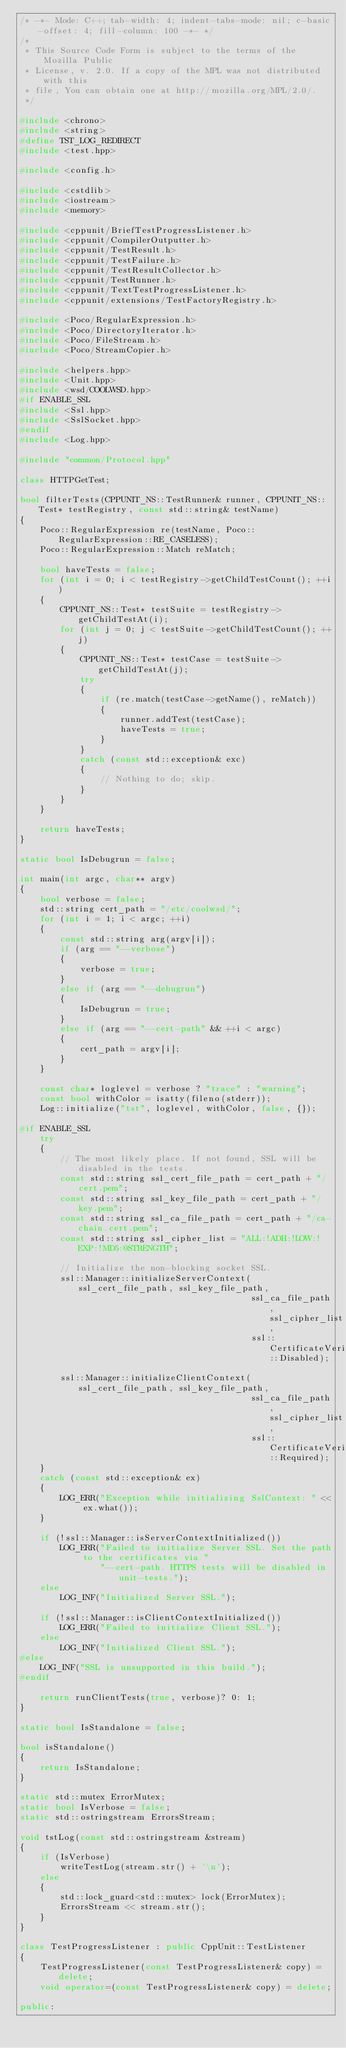Convert code to text. <code><loc_0><loc_0><loc_500><loc_500><_C++_>/* -*- Mode: C++; tab-width: 4; indent-tabs-mode: nil; c-basic-offset: 4; fill-column: 100 -*- */
/*
 * This Source Code Form is subject to the terms of the Mozilla Public
 * License, v. 2.0. If a copy of the MPL was not distributed with this
 * file, You can obtain one at http://mozilla.org/MPL/2.0/.
 */

#include <chrono>
#include <string>
#define TST_LOG_REDIRECT
#include <test.hpp>

#include <config.h>

#include <cstdlib>
#include <iostream>
#include <memory>

#include <cppunit/BriefTestProgressListener.h>
#include <cppunit/CompilerOutputter.h>
#include <cppunit/TestResult.h>
#include <cppunit/TestFailure.h>
#include <cppunit/TestResultCollector.h>
#include <cppunit/TestRunner.h>
#include <cppunit/TextTestProgressListener.h>
#include <cppunit/extensions/TestFactoryRegistry.h>

#include <Poco/RegularExpression.h>
#include <Poco/DirectoryIterator.h>
#include <Poco/FileStream.h>
#include <Poco/StreamCopier.h>

#include <helpers.hpp>
#include <Unit.hpp>
#include <wsd/COOLWSD.hpp>
#if ENABLE_SSL
#include <Ssl.hpp>
#include <SslSocket.hpp>
#endif
#include <Log.hpp>

#include "common/Protocol.hpp"

class HTTPGetTest;

bool filterTests(CPPUNIT_NS::TestRunner& runner, CPPUNIT_NS::Test* testRegistry, const std::string& testName)
{
    Poco::RegularExpression re(testName, Poco::RegularExpression::RE_CASELESS);
    Poco::RegularExpression::Match reMatch;

    bool haveTests = false;
    for (int i = 0; i < testRegistry->getChildTestCount(); ++i)
    {
        CPPUNIT_NS::Test* testSuite = testRegistry->getChildTestAt(i);
        for (int j = 0; j < testSuite->getChildTestCount(); ++j)
        {
            CPPUNIT_NS::Test* testCase = testSuite->getChildTestAt(j);
            try
            {
                if (re.match(testCase->getName(), reMatch))
                {
                    runner.addTest(testCase);
                    haveTests = true;
                }
            }
            catch (const std::exception& exc)
            {
                // Nothing to do; skip.
            }
        }
    }

    return haveTests;
}

static bool IsDebugrun = false;

int main(int argc, char** argv)
{
    bool verbose = false;
    std::string cert_path = "/etc/coolwsd/";
    for (int i = 1; i < argc; ++i)
    {
        const std::string arg(argv[i]);
        if (arg == "--verbose")
        {
            verbose = true;
        }
        else if (arg == "--debugrun")
        {
            IsDebugrun = true;
        }
        else if (arg == "--cert-path" && ++i < argc)
        {
            cert_path = argv[i];
        }
    }

    const char* loglevel = verbose ? "trace" : "warning";
    const bool withColor = isatty(fileno(stderr));
    Log::initialize("tst", loglevel, withColor, false, {});

#if ENABLE_SSL
    try
    {
        // The most likely place. If not found, SSL will be disabled in the tests.
        const std::string ssl_cert_file_path = cert_path + "/cert.pem";
        const std::string ssl_key_file_path = cert_path + "/key.pem";
        const std::string ssl_ca_file_path = cert_path + "/ca-chain.cert.pem";
        const std::string ssl_cipher_list = "ALL:!ADH:!LOW:!EXP:!MD5:@STRENGTH";

        // Initialize the non-blocking socket SSL.
        ssl::Manager::initializeServerContext(ssl_cert_file_path, ssl_key_file_path,
                                              ssl_ca_file_path, ssl_cipher_list,
                                              ssl::CertificateVerification::Disabled);

        ssl::Manager::initializeClientContext(ssl_cert_file_path, ssl_key_file_path,
                                              ssl_ca_file_path, ssl_cipher_list,
                                              ssl::CertificateVerification::Required);
    }
    catch (const std::exception& ex)
    {
        LOG_ERR("Exception while initializing SslContext: " << ex.what());
    }

    if (!ssl::Manager::isServerContextInitialized())
        LOG_ERR("Failed to initialize Server SSL. Set the path to the certificates via "
                "--cert-path. HTTPS tests will be disabled in unit-tests.");
    else
        LOG_INF("Initialized Server SSL.");

    if (!ssl::Manager::isClientContextInitialized())
        LOG_ERR("Failed to initialize Client SSL.");
    else
        LOG_INF("Initialized Client SSL.");
#else
    LOG_INF("SSL is unsupported in this build.");
#endif

    return runClientTests(true, verbose)? 0: 1;
}

static bool IsStandalone = false;

bool isStandalone()
{
    return IsStandalone;
}

static std::mutex ErrorMutex;
static bool IsVerbose = false;
static std::ostringstream ErrorsStream;

void tstLog(const std::ostringstream &stream)
{
    if (IsVerbose)
        writeTestLog(stream.str() + '\n');
    else
    {
        std::lock_guard<std::mutex> lock(ErrorMutex);
        ErrorsStream << stream.str();
    }
}

class TestProgressListener : public CppUnit::TestListener
{
    TestProgressListener(const TestProgressListener& copy) = delete;
    void operator=(const TestProgressListener& copy) = delete;

public:</code> 